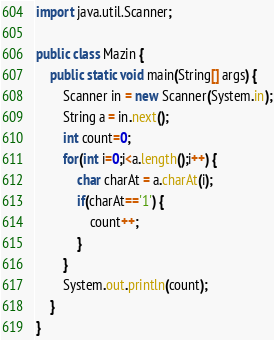<code> <loc_0><loc_0><loc_500><loc_500><_Java_>
import java.util.Scanner;

public class Mazin {
	public static void main(String[] args) {
		Scanner in = new Scanner(System.in);
		String a = in.next();
		int count=0;
		for(int i=0;i<a.length();i++) {
			char charAt = a.charAt(i);
			if(charAt=='1') {
				count++;
			}
		}
		System.out.println(count);
	}
}</code> 